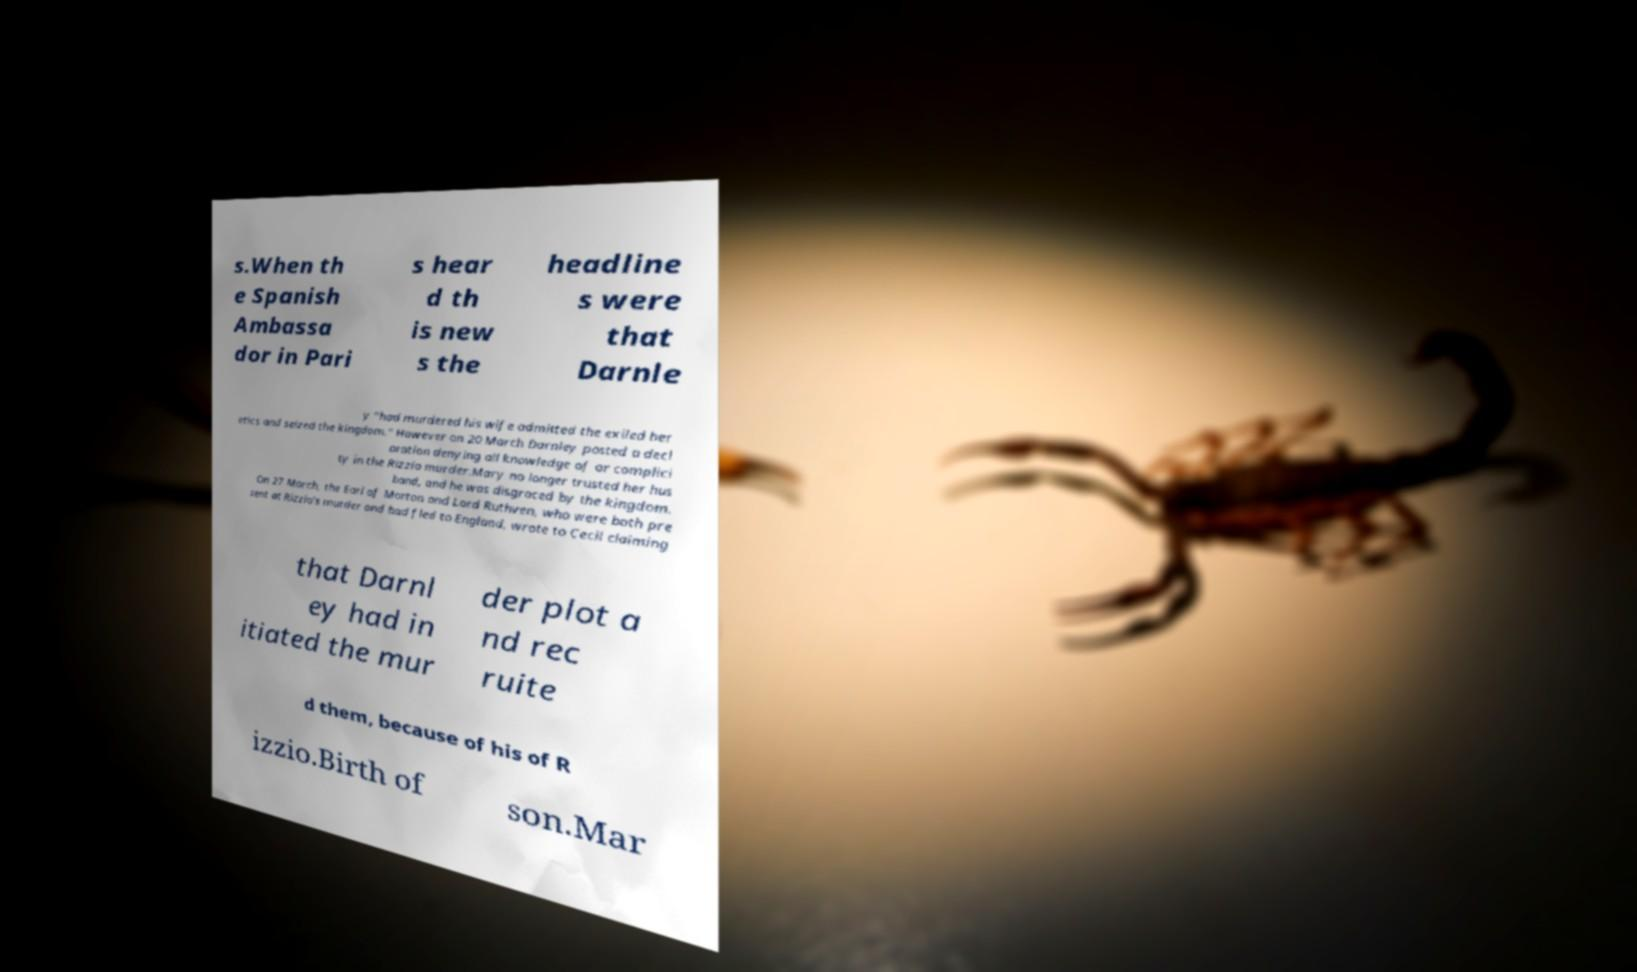What messages or text are displayed in this image? I need them in a readable, typed format. s.When th e Spanish Ambassa dor in Pari s hear d th is new s the headline s were that Darnle y "had murdered his wife admitted the exiled her etics and seized the kingdom." However on 20 March Darnley posted a decl aration denying all knowledge of or complici ty in the Rizzio murder.Mary no longer trusted her hus band, and he was disgraced by the kingdom. On 27 March, the Earl of Morton and Lord Ruthven, who were both pre sent at Rizzio's murder and had fled to England, wrote to Cecil claiming that Darnl ey had in itiated the mur der plot a nd rec ruite d them, because of his of R izzio.Birth of son.Mar 